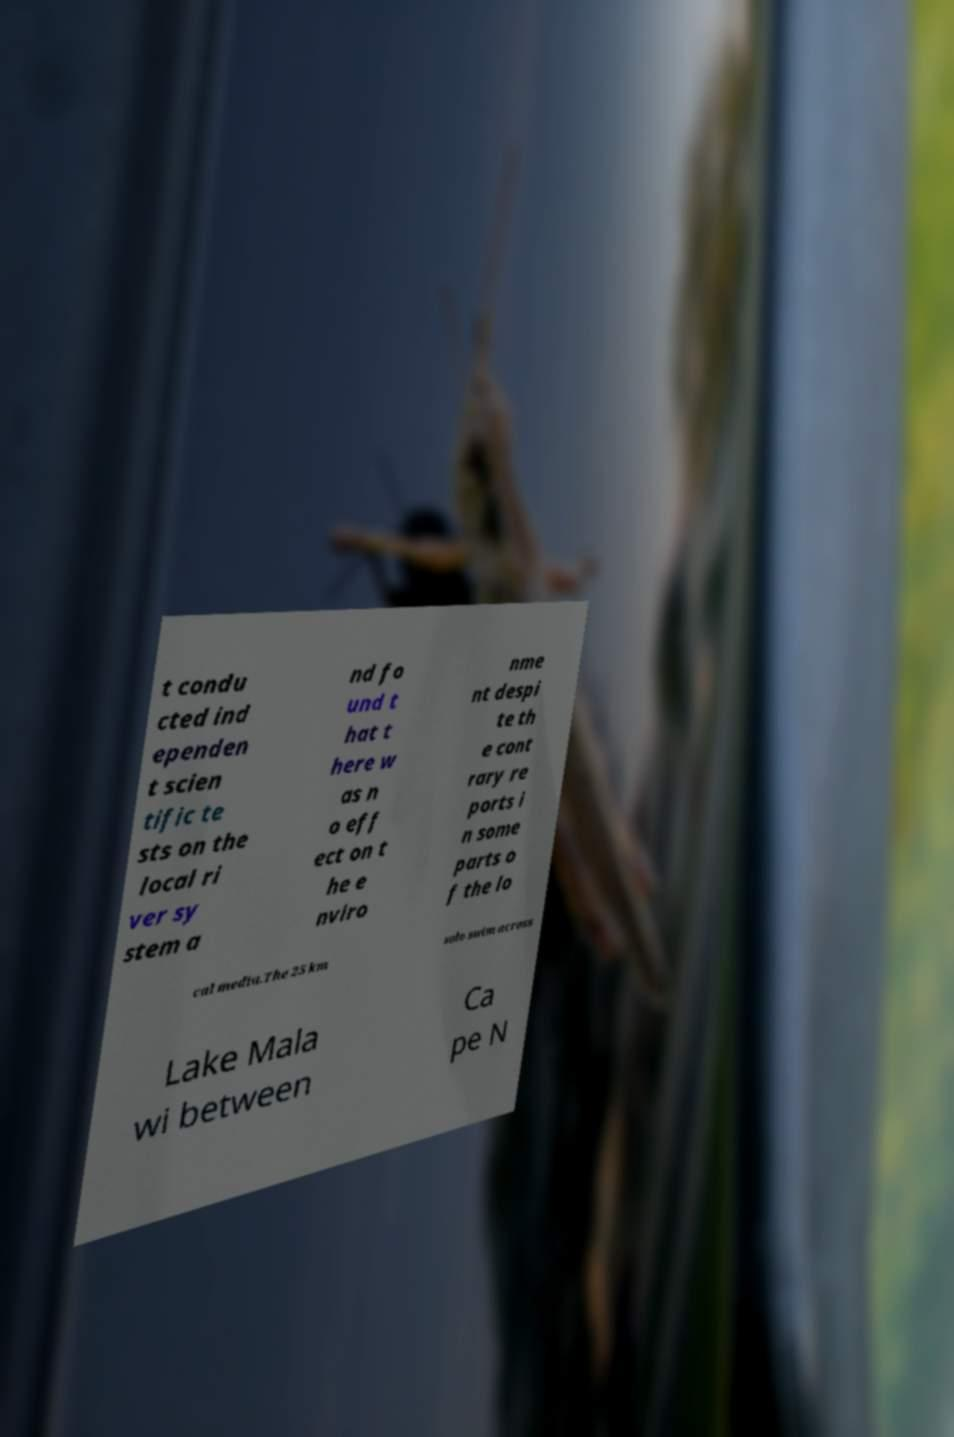Please identify and transcribe the text found in this image. t condu cted ind ependen t scien tific te sts on the local ri ver sy stem a nd fo und t hat t here w as n o eff ect on t he e nviro nme nt despi te th e cont rary re ports i n some parts o f the lo cal media.The 25 km solo swim across Lake Mala wi between Ca pe N 